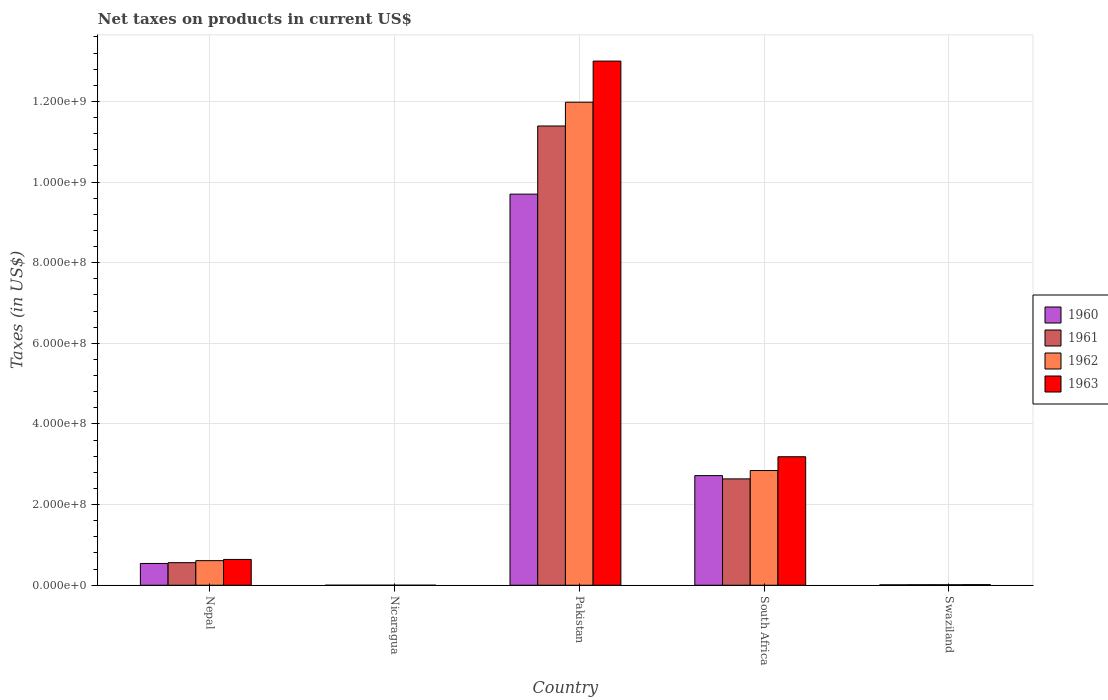How many different coloured bars are there?
Your answer should be very brief. 4. Are the number of bars per tick equal to the number of legend labels?
Keep it short and to the point. Yes. How many bars are there on the 3rd tick from the left?
Make the answer very short. 4. How many bars are there on the 4th tick from the right?
Provide a short and direct response. 4. What is the label of the 4th group of bars from the left?
Give a very brief answer. South Africa. In how many cases, is the number of bars for a given country not equal to the number of legend labels?
Offer a very short reply. 0. What is the net taxes on products in 1960 in Nicaragua?
Make the answer very short. 0.03. Across all countries, what is the maximum net taxes on products in 1962?
Provide a succinct answer. 1.20e+09. Across all countries, what is the minimum net taxes on products in 1963?
Offer a terse response. 0.04. In which country was the net taxes on products in 1962 maximum?
Make the answer very short. Pakistan. In which country was the net taxes on products in 1960 minimum?
Your answer should be compact. Nicaragua. What is the total net taxes on products in 1962 in the graph?
Your response must be concise. 1.54e+09. What is the difference between the net taxes on products in 1962 in Nepal and that in Pakistan?
Give a very brief answer. -1.14e+09. What is the difference between the net taxes on products in 1962 in South Africa and the net taxes on products in 1963 in Swaziland?
Your answer should be very brief. 2.83e+08. What is the average net taxes on products in 1960 per country?
Make the answer very short. 2.59e+08. What is the difference between the net taxes on products of/in 1960 and net taxes on products of/in 1961 in Pakistan?
Your response must be concise. -1.69e+08. In how many countries, is the net taxes on products in 1963 greater than 1000000000 US$?
Provide a short and direct response. 1. What is the ratio of the net taxes on products in 1961 in Nepal to that in South Africa?
Your answer should be very brief. 0.21. What is the difference between the highest and the second highest net taxes on products in 1960?
Offer a very short reply. -6.98e+08. What is the difference between the highest and the lowest net taxes on products in 1963?
Make the answer very short. 1.30e+09. In how many countries, is the net taxes on products in 1962 greater than the average net taxes on products in 1962 taken over all countries?
Provide a short and direct response. 1. Is the sum of the net taxes on products in 1961 in Pakistan and South Africa greater than the maximum net taxes on products in 1960 across all countries?
Make the answer very short. Yes. Is it the case that in every country, the sum of the net taxes on products in 1961 and net taxes on products in 1962 is greater than the sum of net taxes on products in 1960 and net taxes on products in 1963?
Make the answer very short. No. What does the 1st bar from the left in Nepal represents?
Provide a succinct answer. 1960. Is it the case that in every country, the sum of the net taxes on products in 1960 and net taxes on products in 1963 is greater than the net taxes on products in 1962?
Your answer should be very brief. Yes. Are all the bars in the graph horizontal?
Make the answer very short. No. How many countries are there in the graph?
Your answer should be very brief. 5. What is the difference between two consecutive major ticks on the Y-axis?
Provide a succinct answer. 2.00e+08. Are the values on the major ticks of Y-axis written in scientific E-notation?
Your answer should be very brief. Yes. Does the graph contain any zero values?
Ensure brevity in your answer.  No. Does the graph contain grids?
Offer a very short reply. Yes. How are the legend labels stacked?
Keep it short and to the point. Vertical. What is the title of the graph?
Ensure brevity in your answer.  Net taxes on products in current US$. What is the label or title of the Y-axis?
Provide a short and direct response. Taxes (in US$). What is the Taxes (in US$) in 1960 in Nepal?
Offer a very short reply. 5.40e+07. What is the Taxes (in US$) of 1961 in Nepal?
Give a very brief answer. 5.60e+07. What is the Taxes (in US$) of 1962 in Nepal?
Keep it short and to the point. 6.10e+07. What is the Taxes (in US$) of 1963 in Nepal?
Offer a terse response. 6.40e+07. What is the Taxes (in US$) in 1960 in Nicaragua?
Offer a very short reply. 0.03. What is the Taxes (in US$) of 1961 in Nicaragua?
Ensure brevity in your answer.  0.03. What is the Taxes (in US$) in 1962 in Nicaragua?
Your answer should be very brief. 0.04. What is the Taxes (in US$) of 1963 in Nicaragua?
Make the answer very short. 0.04. What is the Taxes (in US$) of 1960 in Pakistan?
Your answer should be compact. 9.70e+08. What is the Taxes (in US$) of 1961 in Pakistan?
Your answer should be compact. 1.14e+09. What is the Taxes (in US$) in 1962 in Pakistan?
Keep it short and to the point. 1.20e+09. What is the Taxes (in US$) in 1963 in Pakistan?
Offer a terse response. 1.30e+09. What is the Taxes (in US$) of 1960 in South Africa?
Your answer should be compact. 2.72e+08. What is the Taxes (in US$) of 1961 in South Africa?
Your answer should be very brief. 2.64e+08. What is the Taxes (in US$) of 1962 in South Africa?
Your answer should be very brief. 2.84e+08. What is the Taxes (in US$) in 1963 in South Africa?
Provide a succinct answer. 3.19e+08. What is the Taxes (in US$) of 1960 in Swaziland?
Provide a short and direct response. 1.00e+06. What is the Taxes (in US$) of 1961 in Swaziland?
Give a very brief answer. 1.21e+06. What is the Taxes (in US$) in 1962 in Swaziland?
Give a very brief answer. 1.24e+06. What is the Taxes (in US$) in 1963 in Swaziland?
Your answer should be very brief. 1.47e+06. Across all countries, what is the maximum Taxes (in US$) of 1960?
Ensure brevity in your answer.  9.70e+08. Across all countries, what is the maximum Taxes (in US$) of 1961?
Ensure brevity in your answer.  1.14e+09. Across all countries, what is the maximum Taxes (in US$) in 1962?
Your answer should be very brief. 1.20e+09. Across all countries, what is the maximum Taxes (in US$) of 1963?
Provide a succinct answer. 1.30e+09. Across all countries, what is the minimum Taxes (in US$) of 1960?
Make the answer very short. 0.03. Across all countries, what is the minimum Taxes (in US$) in 1961?
Your answer should be compact. 0.03. Across all countries, what is the minimum Taxes (in US$) in 1962?
Your answer should be very brief. 0.04. Across all countries, what is the minimum Taxes (in US$) in 1963?
Make the answer very short. 0.04. What is the total Taxes (in US$) of 1960 in the graph?
Your answer should be very brief. 1.30e+09. What is the total Taxes (in US$) of 1961 in the graph?
Keep it short and to the point. 1.46e+09. What is the total Taxes (in US$) in 1962 in the graph?
Provide a succinct answer. 1.54e+09. What is the total Taxes (in US$) in 1963 in the graph?
Give a very brief answer. 1.68e+09. What is the difference between the Taxes (in US$) of 1960 in Nepal and that in Nicaragua?
Your answer should be compact. 5.40e+07. What is the difference between the Taxes (in US$) in 1961 in Nepal and that in Nicaragua?
Offer a terse response. 5.60e+07. What is the difference between the Taxes (in US$) of 1962 in Nepal and that in Nicaragua?
Offer a very short reply. 6.10e+07. What is the difference between the Taxes (in US$) in 1963 in Nepal and that in Nicaragua?
Provide a succinct answer. 6.40e+07. What is the difference between the Taxes (in US$) in 1960 in Nepal and that in Pakistan?
Provide a short and direct response. -9.16e+08. What is the difference between the Taxes (in US$) in 1961 in Nepal and that in Pakistan?
Offer a terse response. -1.08e+09. What is the difference between the Taxes (in US$) of 1962 in Nepal and that in Pakistan?
Offer a very short reply. -1.14e+09. What is the difference between the Taxes (in US$) of 1963 in Nepal and that in Pakistan?
Your response must be concise. -1.24e+09. What is the difference between the Taxes (in US$) of 1960 in Nepal and that in South Africa?
Give a very brief answer. -2.18e+08. What is the difference between the Taxes (in US$) in 1961 in Nepal and that in South Africa?
Keep it short and to the point. -2.08e+08. What is the difference between the Taxes (in US$) of 1962 in Nepal and that in South Africa?
Give a very brief answer. -2.23e+08. What is the difference between the Taxes (in US$) in 1963 in Nepal and that in South Africa?
Provide a succinct answer. -2.55e+08. What is the difference between the Taxes (in US$) of 1960 in Nepal and that in Swaziland?
Your answer should be compact. 5.30e+07. What is the difference between the Taxes (in US$) of 1961 in Nepal and that in Swaziland?
Give a very brief answer. 5.48e+07. What is the difference between the Taxes (in US$) of 1962 in Nepal and that in Swaziland?
Offer a very short reply. 5.98e+07. What is the difference between the Taxes (in US$) of 1963 in Nepal and that in Swaziland?
Your response must be concise. 6.25e+07. What is the difference between the Taxes (in US$) of 1960 in Nicaragua and that in Pakistan?
Keep it short and to the point. -9.70e+08. What is the difference between the Taxes (in US$) of 1961 in Nicaragua and that in Pakistan?
Ensure brevity in your answer.  -1.14e+09. What is the difference between the Taxes (in US$) of 1962 in Nicaragua and that in Pakistan?
Make the answer very short. -1.20e+09. What is the difference between the Taxes (in US$) of 1963 in Nicaragua and that in Pakistan?
Ensure brevity in your answer.  -1.30e+09. What is the difference between the Taxes (in US$) of 1960 in Nicaragua and that in South Africa?
Your response must be concise. -2.72e+08. What is the difference between the Taxes (in US$) in 1961 in Nicaragua and that in South Africa?
Your answer should be very brief. -2.64e+08. What is the difference between the Taxes (in US$) of 1962 in Nicaragua and that in South Africa?
Make the answer very short. -2.84e+08. What is the difference between the Taxes (in US$) of 1963 in Nicaragua and that in South Africa?
Give a very brief answer. -3.19e+08. What is the difference between the Taxes (in US$) in 1960 in Nicaragua and that in Swaziland?
Your answer should be compact. -1.00e+06. What is the difference between the Taxes (in US$) in 1961 in Nicaragua and that in Swaziland?
Provide a succinct answer. -1.21e+06. What is the difference between the Taxes (in US$) of 1962 in Nicaragua and that in Swaziland?
Offer a very short reply. -1.24e+06. What is the difference between the Taxes (in US$) of 1963 in Nicaragua and that in Swaziland?
Give a very brief answer. -1.47e+06. What is the difference between the Taxes (in US$) in 1960 in Pakistan and that in South Africa?
Offer a very short reply. 6.98e+08. What is the difference between the Taxes (in US$) of 1961 in Pakistan and that in South Africa?
Your answer should be very brief. 8.75e+08. What is the difference between the Taxes (in US$) of 1962 in Pakistan and that in South Africa?
Give a very brief answer. 9.14e+08. What is the difference between the Taxes (in US$) in 1963 in Pakistan and that in South Africa?
Offer a very short reply. 9.81e+08. What is the difference between the Taxes (in US$) in 1960 in Pakistan and that in Swaziland?
Ensure brevity in your answer.  9.69e+08. What is the difference between the Taxes (in US$) in 1961 in Pakistan and that in Swaziland?
Provide a short and direct response. 1.14e+09. What is the difference between the Taxes (in US$) in 1962 in Pakistan and that in Swaziland?
Your answer should be very brief. 1.20e+09. What is the difference between the Taxes (in US$) of 1963 in Pakistan and that in Swaziland?
Provide a short and direct response. 1.30e+09. What is the difference between the Taxes (in US$) of 1960 in South Africa and that in Swaziland?
Provide a succinct answer. 2.71e+08. What is the difference between the Taxes (in US$) of 1961 in South Africa and that in Swaziland?
Provide a short and direct response. 2.63e+08. What is the difference between the Taxes (in US$) in 1962 in South Africa and that in Swaziland?
Provide a short and direct response. 2.83e+08. What is the difference between the Taxes (in US$) of 1963 in South Africa and that in Swaziland?
Your response must be concise. 3.17e+08. What is the difference between the Taxes (in US$) in 1960 in Nepal and the Taxes (in US$) in 1961 in Nicaragua?
Your answer should be very brief. 5.40e+07. What is the difference between the Taxes (in US$) of 1960 in Nepal and the Taxes (in US$) of 1962 in Nicaragua?
Offer a terse response. 5.40e+07. What is the difference between the Taxes (in US$) in 1960 in Nepal and the Taxes (in US$) in 1963 in Nicaragua?
Make the answer very short. 5.40e+07. What is the difference between the Taxes (in US$) of 1961 in Nepal and the Taxes (in US$) of 1962 in Nicaragua?
Keep it short and to the point. 5.60e+07. What is the difference between the Taxes (in US$) in 1961 in Nepal and the Taxes (in US$) in 1963 in Nicaragua?
Your answer should be compact. 5.60e+07. What is the difference between the Taxes (in US$) in 1962 in Nepal and the Taxes (in US$) in 1963 in Nicaragua?
Offer a very short reply. 6.10e+07. What is the difference between the Taxes (in US$) in 1960 in Nepal and the Taxes (in US$) in 1961 in Pakistan?
Your answer should be compact. -1.08e+09. What is the difference between the Taxes (in US$) in 1960 in Nepal and the Taxes (in US$) in 1962 in Pakistan?
Make the answer very short. -1.14e+09. What is the difference between the Taxes (in US$) in 1960 in Nepal and the Taxes (in US$) in 1963 in Pakistan?
Your response must be concise. -1.25e+09. What is the difference between the Taxes (in US$) of 1961 in Nepal and the Taxes (in US$) of 1962 in Pakistan?
Give a very brief answer. -1.14e+09. What is the difference between the Taxes (in US$) in 1961 in Nepal and the Taxes (in US$) in 1963 in Pakistan?
Your answer should be compact. -1.24e+09. What is the difference between the Taxes (in US$) in 1962 in Nepal and the Taxes (in US$) in 1963 in Pakistan?
Your answer should be very brief. -1.24e+09. What is the difference between the Taxes (in US$) of 1960 in Nepal and the Taxes (in US$) of 1961 in South Africa?
Offer a terse response. -2.10e+08. What is the difference between the Taxes (in US$) of 1960 in Nepal and the Taxes (in US$) of 1962 in South Africa?
Offer a very short reply. -2.30e+08. What is the difference between the Taxes (in US$) in 1960 in Nepal and the Taxes (in US$) in 1963 in South Africa?
Offer a very short reply. -2.65e+08. What is the difference between the Taxes (in US$) in 1961 in Nepal and the Taxes (in US$) in 1962 in South Africa?
Your answer should be very brief. -2.28e+08. What is the difference between the Taxes (in US$) in 1961 in Nepal and the Taxes (in US$) in 1963 in South Africa?
Your answer should be compact. -2.63e+08. What is the difference between the Taxes (in US$) in 1962 in Nepal and the Taxes (in US$) in 1963 in South Africa?
Your answer should be very brief. -2.58e+08. What is the difference between the Taxes (in US$) of 1960 in Nepal and the Taxes (in US$) of 1961 in Swaziland?
Ensure brevity in your answer.  5.28e+07. What is the difference between the Taxes (in US$) in 1960 in Nepal and the Taxes (in US$) in 1962 in Swaziland?
Your answer should be compact. 5.28e+07. What is the difference between the Taxes (in US$) in 1960 in Nepal and the Taxes (in US$) in 1963 in Swaziland?
Your response must be concise. 5.25e+07. What is the difference between the Taxes (in US$) of 1961 in Nepal and the Taxes (in US$) of 1962 in Swaziland?
Provide a short and direct response. 5.48e+07. What is the difference between the Taxes (in US$) in 1961 in Nepal and the Taxes (in US$) in 1963 in Swaziland?
Ensure brevity in your answer.  5.45e+07. What is the difference between the Taxes (in US$) of 1962 in Nepal and the Taxes (in US$) of 1963 in Swaziland?
Make the answer very short. 5.95e+07. What is the difference between the Taxes (in US$) of 1960 in Nicaragua and the Taxes (in US$) of 1961 in Pakistan?
Make the answer very short. -1.14e+09. What is the difference between the Taxes (in US$) in 1960 in Nicaragua and the Taxes (in US$) in 1962 in Pakistan?
Provide a short and direct response. -1.20e+09. What is the difference between the Taxes (in US$) of 1960 in Nicaragua and the Taxes (in US$) of 1963 in Pakistan?
Give a very brief answer. -1.30e+09. What is the difference between the Taxes (in US$) of 1961 in Nicaragua and the Taxes (in US$) of 1962 in Pakistan?
Offer a terse response. -1.20e+09. What is the difference between the Taxes (in US$) in 1961 in Nicaragua and the Taxes (in US$) in 1963 in Pakistan?
Ensure brevity in your answer.  -1.30e+09. What is the difference between the Taxes (in US$) in 1962 in Nicaragua and the Taxes (in US$) in 1963 in Pakistan?
Make the answer very short. -1.30e+09. What is the difference between the Taxes (in US$) in 1960 in Nicaragua and the Taxes (in US$) in 1961 in South Africa?
Provide a short and direct response. -2.64e+08. What is the difference between the Taxes (in US$) in 1960 in Nicaragua and the Taxes (in US$) in 1962 in South Africa?
Offer a very short reply. -2.84e+08. What is the difference between the Taxes (in US$) of 1960 in Nicaragua and the Taxes (in US$) of 1963 in South Africa?
Your answer should be very brief. -3.19e+08. What is the difference between the Taxes (in US$) of 1961 in Nicaragua and the Taxes (in US$) of 1962 in South Africa?
Offer a very short reply. -2.84e+08. What is the difference between the Taxes (in US$) in 1961 in Nicaragua and the Taxes (in US$) in 1963 in South Africa?
Offer a terse response. -3.19e+08. What is the difference between the Taxes (in US$) of 1962 in Nicaragua and the Taxes (in US$) of 1963 in South Africa?
Provide a short and direct response. -3.19e+08. What is the difference between the Taxes (in US$) in 1960 in Nicaragua and the Taxes (in US$) in 1961 in Swaziland?
Provide a short and direct response. -1.21e+06. What is the difference between the Taxes (in US$) of 1960 in Nicaragua and the Taxes (in US$) of 1962 in Swaziland?
Give a very brief answer. -1.24e+06. What is the difference between the Taxes (in US$) in 1960 in Nicaragua and the Taxes (in US$) in 1963 in Swaziland?
Provide a succinct answer. -1.47e+06. What is the difference between the Taxes (in US$) in 1961 in Nicaragua and the Taxes (in US$) in 1962 in Swaziland?
Make the answer very short. -1.24e+06. What is the difference between the Taxes (in US$) in 1961 in Nicaragua and the Taxes (in US$) in 1963 in Swaziland?
Your answer should be very brief. -1.47e+06. What is the difference between the Taxes (in US$) in 1962 in Nicaragua and the Taxes (in US$) in 1963 in Swaziland?
Provide a succinct answer. -1.47e+06. What is the difference between the Taxes (in US$) in 1960 in Pakistan and the Taxes (in US$) in 1961 in South Africa?
Provide a short and direct response. 7.06e+08. What is the difference between the Taxes (in US$) in 1960 in Pakistan and the Taxes (in US$) in 1962 in South Africa?
Your answer should be compact. 6.86e+08. What is the difference between the Taxes (in US$) in 1960 in Pakistan and the Taxes (in US$) in 1963 in South Africa?
Ensure brevity in your answer.  6.51e+08. What is the difference between the Taxes (in US$) of 1961 in Pakistan and the Taxes (in US$) of 1962 in South Africa?
Make the answer very short. 8.55e+08. What is the difference between the Taxes (in US$) in 1961 in Pakistan and the Taxes (in US$) in 1963 in South Africa?
Offer a very short reply. 8.20e+08. What is the difference between the Taxes (in US$) of 1962 in Pakistan and the Taxes (in US$) of 1963 in South Africa?
Your answer should be compact. 8.79e+08. What is the difference between the Taxes (in US$) of 1960 in Pakistan and the Taxes (in US$) of 1961 in Swaziland?
Keep it short and to the point. 9.69e+08. What is the difference between the Taxes (in US$) of 1960 in Pakistan and the Taxes (in US$) of 1962 in Swaziland?
Provide a short and direct response. 9.69e+08. What is the difference between the Taxes (in US$) of 1960 in Pakistan and the Taxes (in US$) of 1963 in Swaziland?
Your answer should be very brief. 9.69e+08. What is the difference between the Taxes (in US$) in 1961 in Pakistan and the Taxes (in US$) in 1962 in Swaziland?
Provide a succinct answer. 1.14e+09. What is the difference between the Taxes (in US$) in 1961 in Pakistan and the Taxes (in US$) in 1963 in Swaziland?
Provide a succinct answer. 1.14e+09. What is the difference between the Taxes (in US$) of 1962 in Pakistan and the Taxes (in US$) of 1963 in Swaziland?
Provide a short and direct response. 1.20e+09. What is the difference between the Taxes (in US$) in 1960 in South Africa and the Taxes (in US$) in 1961 in Swaziland?
Your answer should be very brief. 2.71e+08. What is the difference between the Taxes (in US$) in 1960 in South Africa and the Taxes (in US$) in 1962 in Swaziland?
Provide a succinct answer. 2.71e+08. What is the difference between the Taxes (in US$) in 1960 in South Africa and the Taxes (in US$) in 1963 in Swaziland?
Offer a very short reply. 2.70e+08. What is the difference between the Taxes (in US$) in 1961 in South Africa and the Taxes (in US$) in 1962 in Swaziland?
Your answer should be compact. 2.63e+08. What is the difference between the Taxes (in US$) of 1961 in South Africa and the Taxes (in US$) of 1963 in Swaziland?
Your answer should be very brief. 2.62e+08. What is the difference between the Taxes (in US$) in 1962 in South Africa and the Taxes (in US$) in 1963 in Swaziland?
Provide a short and direct response. 2.83e+08. What is the average Taxes (in US$) of 1960 per country?
Provide a succinct answer. 2.59e+08. What is the average Taxes (in US$) in 1961 per country?
Provide a short and direct response. 2.92e+08. What is the average Taxes (in US$) in 1962 per country?
Your answer should be compact. 3.09e+08. What is the average Taxes (in US$) in 1963 per country?
Provide a short and direct response. 3.37e+08. What is the difference between the Taxes (in US$) of 1960 and Taxes (in US$) of 1962 in Nepal?
Give a very brief answer. -7.00e+06. What is the difference between the Taxes (in US$) of 1960 and Taxes (in US$) of 1963 in Nepal?
Offer a very short reply. -1.00e+07. What is the difference between the Taxes (in US$) in 1961 and Taxes (in US$) in 1962 in Nepal?
Give a very brief answer. -5.00e+06. What is the difference between the Taxes (in US$) in 1961 and Taxes (in US$) in 1963 in Nepal?
Ensure brevity in your answer.  -8.00e+06. What is the difference between the Taxes (in US$) in 1962 and Taxes (in US$) in 1963 in Nepal?
Offer a terse response. -3.00e+06. What is the difference between the Taxes (in US$) in 1960 and Taxes (in US$) in 1961 in Nicaragua?
Provide a short and direct response. -0. What is the difference between the Taxes (in US$) of 1960 and Taxes (in US$) of 1962 in Nicaragua?
Give a very brief answer. -0.01. What is the difference between the Taxes (in US$) of 1960 and Taxes (in US$) of 1963 in Nicaragua?
Offer a very short reply. -0.01. What is the difference between the Taxes (in US$) of 1961 and Taxes (in US$) of 1962 in Nicaragua?
Provide a succinct answer. -0. What is the difference between the Taxes (in US$) in 1961 and Taxes (in US$) in 1963 in Nicaragua?
Provide a short and direct response. -0.01. What is the difference between the Taxes (in US$) of 1962 and Taxes (in US$) of 1963 in Nicaragua?
Your answer should be compact. -0.01. What is the difference between the Taxes (in US$) of 1960 and Taxes (in US$) of 1961 in Pakistan?
Your answer should be compact. -1.69e+08. What is the difference between the Taxes (in US$) of 1960 and Taxes (in US$) of 1962 in Pakistan?
Make the answer very short. -2.28e+08. What is the difference between the Taxes (in US$) in 1960 and Taxes (in US$) in 1963 in Pakistan?
Keep it short and to the point. -3.30e+08. What is the difference between the Taxes (in US$) of 1961 and Taxes (in US$) of 1962 in Pakistan?
Keep it short and to the point. -5.90e+07. What is the difference between the Taxes (in US$) of 1961 and Taxes (in US$) of 1963 in Pakistan?
Ensure brevity in your answer.  -1.61e+08. What is the difference between the Taxes (in US$) in 1962 and Taxes (in US$) in 1963 in Pakistan?
Your answer should be very brief. -1.02e+08. What is the difference between the Taxes (in US$) in 1960 and Taxes (in US$) in 1961 in South Africa?
Offer a terse response. 8.10e+06. What is the difference between the Taxes (in US$) in 1960 and Taxes (in US$) in 1962 in South Africa?
Your answer should be very brief. -1.26e+07. What is the difference between the Taxes (in US$) of 1960 and Taxes (in US$) of 1963 in South Africa?
Ensure brevity in your answer.  -4.68e+07. What is the difference between the Taxes (in US$) in 1961 and Taxes (in US$) in 1962 in South Africa?
Your response must be concise. -2.07e+07. What is the difference between the Taxes (in US$) of 1961 and Taxes (in US$) of 1963 in South Africa?
Make the answer very short. -5.49e+07. What is the difference between the Taxes (in US$) in 1962 and Taxes (in US$) in 1963 in South Africa?
Your response must be concise. -3.42e+07. What is the difference between the Taxes (in US$) in 1960 and Taxes (in US$) in 1961 in Swaziland?
Your answer should be very brief. -2.06e+05. What is the difference between the Taxes (in US$) of 1960 and Taxes (in US$) of 1962 in Swaziland?
Provide a short and direct response. -2.36e+05. What is the difference between the Taxes (in US$) of 1960 and Taxes (in US$) of 1963 in Swaziland?
Offer a very short reply. -4.72e+05. What is the difference between the Taxes (in US$) of 1961 and Taxes (in US$) of 1962 in Swaziland?
Offer a very short reply. -2.95e+04. What is the difference between the Taxes (in US$) in 1961 and Taxes (in US$) in 1963 in Swaziland?
Your answer should be compact. -2.65e+05. What is the difference between the Taxes (in US$) of 1962 and Taxes (in US$) of 1963 in Swaziland?
Give a very brief answer. -2.36e+05. What is the ratio of the Taxes (in US$) of 1960 in Nepal to that in Nicaragua?
Give a very brief answer. 1.81e+09. What is the ratio of the Taxes (in US$) in 1961 in Nepal to that in Nicaragua?
Offer a terse response. 1.80e+09. What is the ratio of the Taxes (in US$) of 1962 in Nepal to that in Nicaragua?
Your answer should be compact. 1.73e+09. What is the ratio of the Taxes (in US$) of 1963 in Nepal to that in Nicaragua?
Give a very brief answer. 1.54e+09. What is the ratio of the Taxes (in US$) in 1960 in Nepal to that in Pakistan?
Keep it short and to the point. 0.06. What is the ratio of the Taxes (in US$) of 1961 in Nepal to that in Pakistan?
Provide a succinct answer. 0.05. What is the ratio of the Taxes (in US$) of 1962 in Nepal to that in Pakistan?
Make the answer very short. 0.05. What is the ratio of the Taxes (in US$) in 1963 in Nepal to that in Pakistan?
Make the answer very short. 0.05. What is the ratio of the Taxes (in US$) in 1960 in Nepal to that in South Africa?
Ensure brevity in your answer.  0.2. What is the ratio of the Taxes (in US$) in 1961 in Nepal to that in South Africa?
Provide a succinct answer. 0.21. What is the ratio of the Taxes (in US$) of 1962 in Nepal to that in South Africa?
Keep it short and to the point. 0.21. What is the ratio of the Taxes (in US$) in 1963 in Nepal to that in South Africa?
Your answer should be very brief. 0.2. What is the ratio of the Taxes (in US$) of 1960 in Nepal to that in Swaziland?
Provide a short and direct response. 53.86. What is the ratio of the Taxes (in US$) of 1961 in Nepal to that in Swaziland?
Give a very brief answer. 46.32. What is the ratio of the Taxes (in US$) in 1962 in Nepal to that in Swaziland?
Keep it short and to the point. 49.25. What is the ratio of the Taxes (in US$) in 1963 in Nepal to that in Swaziland?
Provide a short and direct response. 43.41. What is the ratio of the Taxes (in US$) in 1960 in Nicaragua to that in Pakistan?
Make the answer very short. 0. What is the ratio of the Taxes (in US$) of 1962 in Nicaragua to that in Swaziland?
Keep it short and to the point. 0. What is the ratio of the Taxes (in US$) of 1960 in Pakistan to that in South Africa?
Provide a succinct answer. 3.57. What is the ratio of the Taxes (in US$) of 1961 in Pakistan to that in South Africa?
Offer a terse response. 4.32. What is the ratio of the Taxes (in US$) of 1962 in Pakistan to that in South Africa?
Provide a succinct answer. 4.21. What is the ratio of the Taxes (in US$) in 1963 in Pakistan to that in South Africa?
Provide a succinct answer. 4.08. What is the ratio of the Taxes (in US$) of 1960 in Pakistan to that in Swaziland?
Provide a succinct answer. 967.48. What is the ratio of the Taxes (in US$) of 1961 in Pakistan to that in Swaziland?
Give a very brief answer. 942.1. What is the ratio of the Taxes (in US$) in 1962 in Pakistan to that in Swaziland?
Your response must be concise. 967.3. What is the ratio of the Taxes (in US$) of 1963 in Pakistan to that in Swaziland?
Ensure brevity in your answer.  881.71. What is the ratio of the Taxes (in US$) of 1960 in South Africa to that in Swaziland?
Provide a succinct answer. 271.17. What is the ratio of the Taxes (in US$) in 1961 in South Africa to that in Swaziland?
Ensure brevity in your answer.  218.17. What is the ratio of the Taxes (in US$) of 1962 in South Africa to that in Swaziland?
Provide a succinct answer. 229.69. What is the ratio of the Taxes (in US$) in 1963 in South Africa to that in Swaziland?
Keep it short and to the point. 216.15. What is the difference between the highest and the second highest Taxes (in US$) of 1960?
Ensure brevity in your answer.  6.98e+08. What is the difference between the highest and the second highest Taxes (in US$) of 1961?
Your response must be concise. 8.75e+08. What is the difference between the highest and the second highest Taxes (in US$) of 1962?
Provide a succinct answer. 9.14e+08. What is the difference between the highest and the second highest Taxes (in US$) of 1963?
Your response must be concise. 9.81e+08. What is the difference between the highest and the lowest Taxes (in US$) in 1960?
Provide a short and direct response. 9.70e+08. What is the difference between the highest and the lowest Taxes (in US$) in 1961?
Your answer should be very brief. 1.14e+09. What is the difference between the highest and the lowest Taxes (in US$) in 1962?
Offer a very short reply. 1.20e+09. What is the difference between the highest and the lowest Taxes (in US$) of 1963?
Your answer should be very brief. 1.30e+09. 